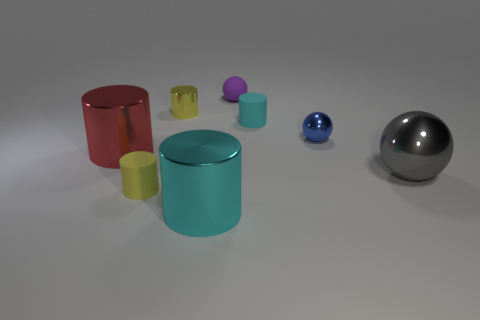Subtract all big shiny cylinders. How many cylinders are left? 3 Subtract all blue spheres. How many spheres are left? 2 Subtract all cyan blocks. How many cyan cylinders are left? 2 Add 1 large red metal cylinders. How many objects exist? 9 Add 1 large blue cylinders. How many large blue cylinders exist? 1 Subtract 0 green cubes. How many objects are left? 8 Subtract all spheres. How many objects are left? 5 Subtract all purple cylinders. Subtract all blue cubes. How many cylinders are left? 5 Subtract all cyan metal cylinders. Subtract all blue cylinders. How many objects are left? 7 Add 3 cyan cylinders. How many cyan cylinders are left? 5 